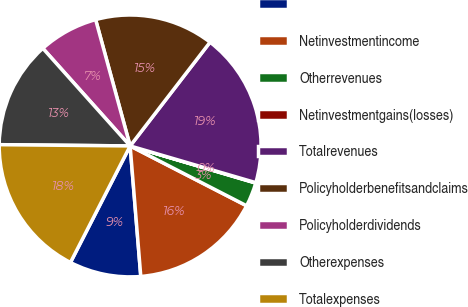<chart> <loc_0><loc_0><loc_500><loc_500><pie_chart><ecel><fcel>Netinvestmentincome<fcel>Otherrevenues<fcel>Netinvestmentgains(losses)<fcel>Totalrevenues<fcel>Policyholderbenefitsandclaims<fcel>Policyholderdividends<fcel>Otherexpenses<fcel>Totalexpenses<nl><fcel>8.83%<fcel>16.15%<fcel>2.98%<fcel>0.05%<fcel>19.08%<fcel>14.69%<fcel>7.37%<fcel>13.23%<fcel>17.62%<nl></chart> 